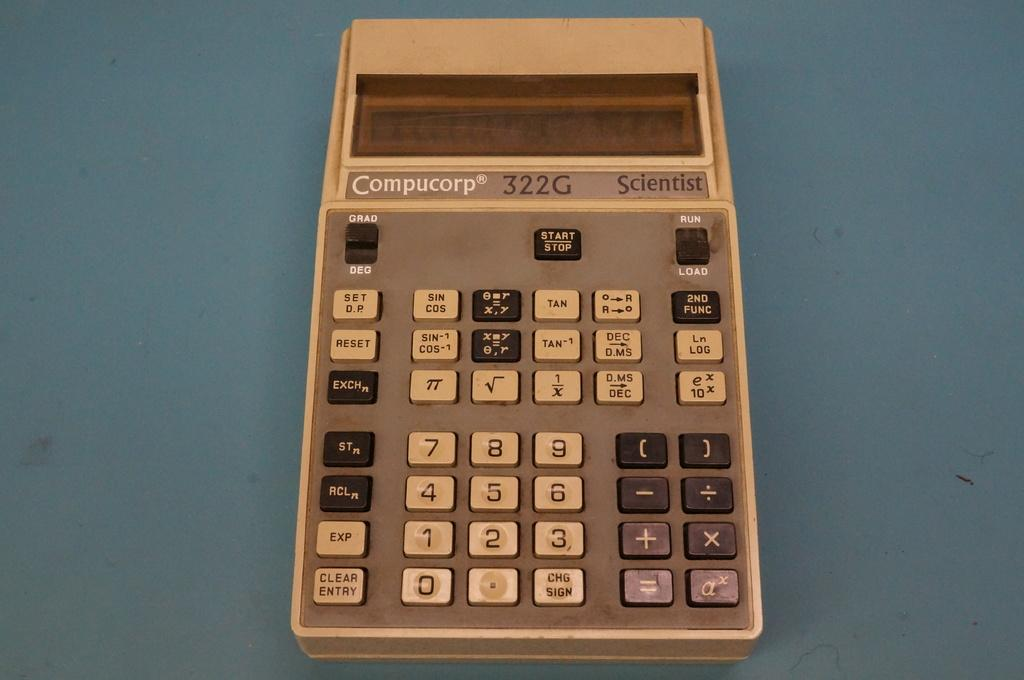Provide a one-sentence caption for the provided image. An ancient Compucorp 332G calculator, beige and with the basic buttons calculators had twenty years ago. 